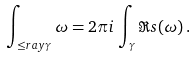<formula> <loc_0><loc_0><loc_500><loc_500>\int _ { \leq r a y \gamma } \omega = 2 \pi i \, \int _ { \gamma } \Re s ( \omega ) \, .</formula> 